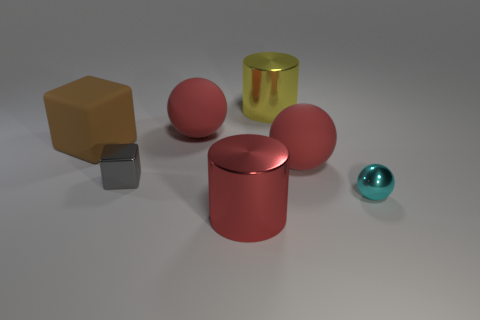Subtract all big red rubber balls. How many balls are left? 1 Add 2 gray shiny blocks. How many objects exist? 9 Subtract all blue cylinders. How many cyan balls are left? 1 Subtract all large blue metal cubes. Subtract all big brown objects. How many objects are left? 6 Add 4 metallic spheres. How many metallic spheres are left? 5 Add 4 cyan shiny things. How many cyan shiny things exist? 5 Subtract all red balls. How many balls are left? 1 Subtract 0 purple cylinders. How many objects are left? 7 Subtract all spheres. How many objects are left? 4 Subtract 1 cylinders. How many cylinders are left? 1 